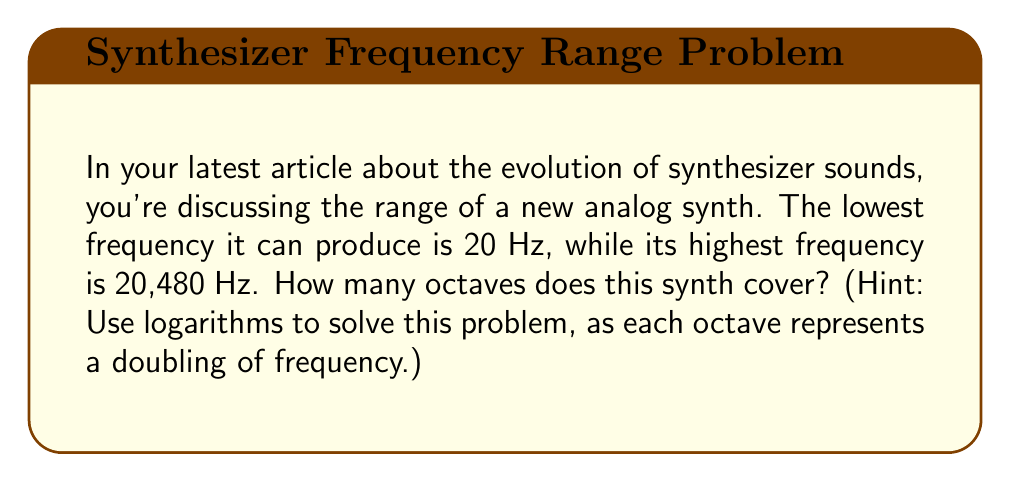What is the answer to this math problem? Let's approach this step-by-step:

1) An octave is a doubling of frequency. So, we need to find how many times we need to double 20 Hz to reach 20,480 Hz.

2) We can express this mathematically as:
   $20 \cdot 2^n = 20,480$, where $n$ is the number of octaves.

3) Dividing both sides by 20:
   $2^n = 1,024$

4) To solve for $n$, we need to use logarithms. Taking $\log_2$ of both sides:
   $\log_2(2^n) = \log_2(1,024)$

5) Using the logarithm property $\log_a(a^x) = x$:
   $n = \log_2(1,024)$

6) We can calculate this:
   $n = \log_2(1,024) = 10$

Therefore, the synthesizer covers 10 octaves.

Note: We can verify this: $20 \cdot 2^{10} = 20 \cdot 1,024 = 20,480$
Answer: 10 octaves 